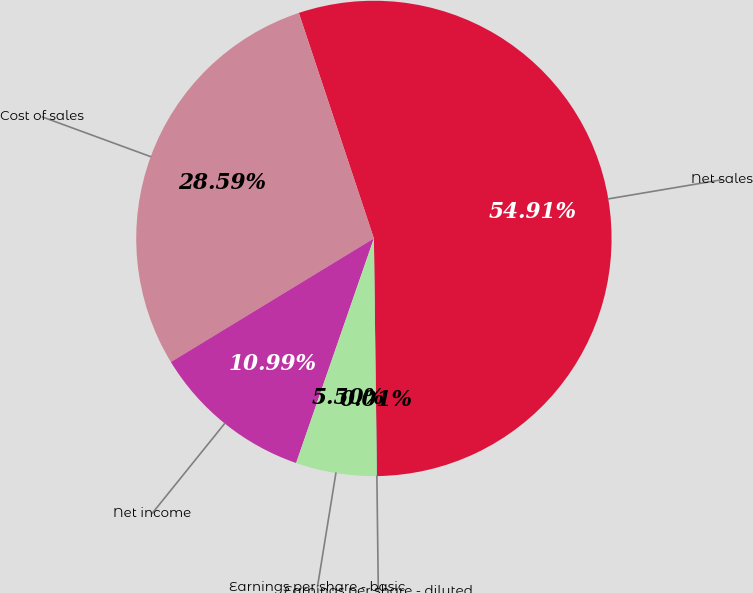Convert chart to OTSL. <chart><loc_0><loc_0><loc_500><loc_500><pie_chart><fcel>Net sales<fcel>Cost of sales<fcel>Net income<fcel>Earnings per share - basic<fcel>Earnings per share - diluted<nl><fcel>54.91%<fcel>28.59%<fcel>10.99%<fcel>5.5%<fcel>0.01%<nl></chart> 